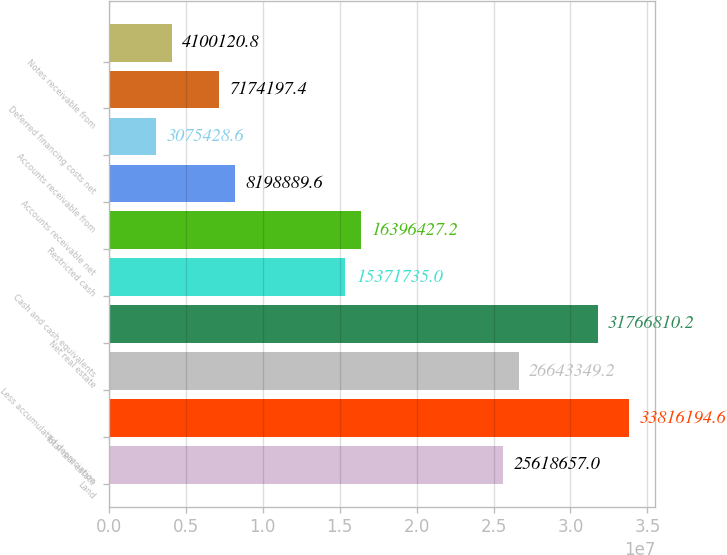Convert chart. <chart><loc_0><loc_0><loc_500><loc_500><bar_chart><fcel>Land<fcel>Total real estate<fcel>Less accumulated depreciation<fcel>Net real estate<fcel>Cash and cash equivalents<fcel>Restricted cash<fcel>Accounts receivable net<fcel>Accounts receivable from<fcel>Deferred financing costs net<fcel>Notes receivable from<nl><fcel>2.56187e+07<fcel>3.38162e+07<fcel>2.66433e+07<fcel>3.17668e+07<fcel>1.53717e+07<fcel>1.63964e+07<fcel>8.19889e+06<fcel>3.07543e+06<fcel>7.1742e+06<fcel>4.10012e+06<nl></chart> 